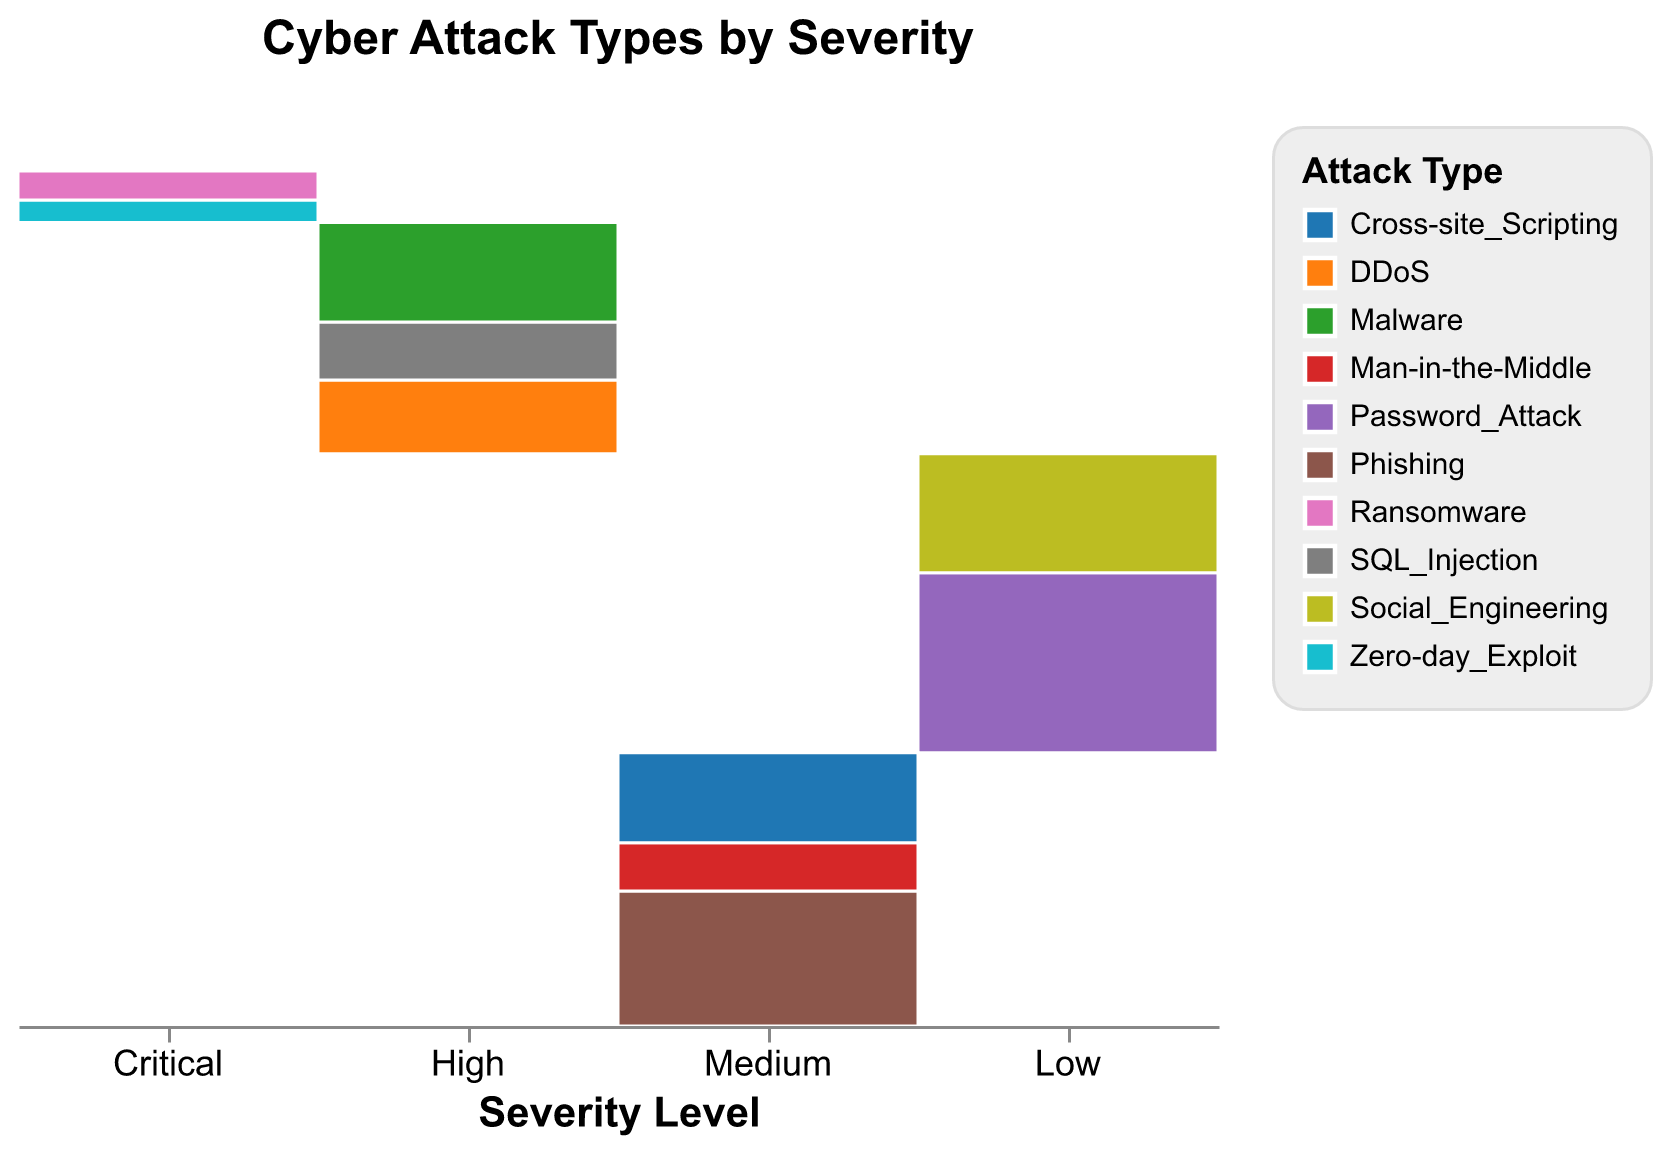Which attack type has the highest frequency? Identify the color bar with the highest percentage and read the corresponding value from the tooltip or color legend. Password_Attack has a frequency of 56.
Answer: Password_Attack What are the severity levels of DDoS attacks? Locate the color bar for DDoS attacks and look at the x-axis to find the severity levels. DDoS attacks are in the 'High' severity category.
Answer: High Which severity level has the most attack types? Count the number of unique attack types within each severity level. The Medium severity level has the most attack types (Phishing, Man-in-the-Middle, Cross-site Scripting).
Answer: Medium How many attack types have medium severity? Locate the Medium section on the x-axis and count the number of different colored rectangles within it. There are 3 attack types with medium severity: Phishing, Man-in-the-Middle, Cross-site Scripting.
Answer: 3 Which attack type has the highest proportion within the high severity level? Look at the High section and check which color bar is tallest within that category. Malware has the highest proportion within the high severity level.
Answer: Malware What percentage of critical severity attacks are Zero-day Exploits? Hover over or refer to the tooltip for the color bar representing Zero-day Exploit and read the percentage value in the critical section. Zero-day Exploits constitute about 43.8% of critical severity attacks.
Answer: 43.8% Compare the frequencies of high severity attacks. Which one is the least and the most frequent? Look at the High severity section and compare the lengths of the different color bars. The most frequent high severity attack is Malware (31), and the least frequent is SQL Injection (18).
Answer: Most frequent: Malware, Least frequent: SQL Injection What is the total number of attacks in the low severity category? Sum the frequencies of all attack types in the Low severity category: 56 (Password_Attack) + 37 (Social_Engineering) = 93.
Answer: 93 Which severity level has the least total frequency? Compare the total heights of the bars for each severity level and identify the smallest one. The Critical severity level has the least total frequency: 7 (Zero-day_Exploit) + 9 (Ransomware) = 16.
Answer: Critical What is the total number of medium severity attacks? Sum the frequencies of all attack types in the Medium severity category: 42 (Phishing) + 15 (Man-in-the-Middle) + 28 (Cross-site Scripting) = 85.
Answer: 85 